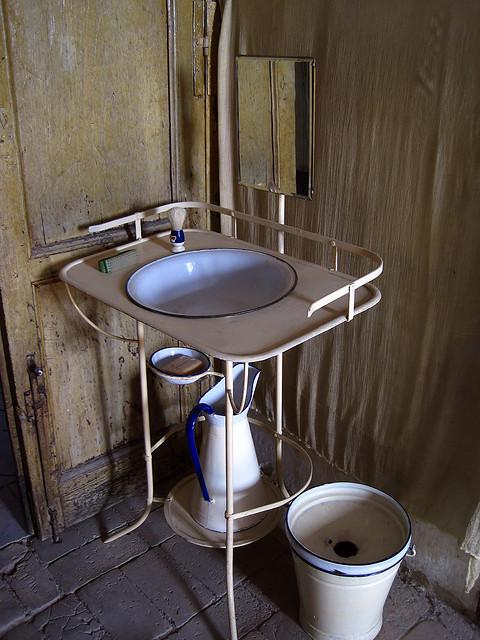What color is the handle on the pitcher?
Give a very brief answer. Blue. Is this a toilet?
Keep it brief. No. What type of room is this?
Write a very short answer. Bathroom. 